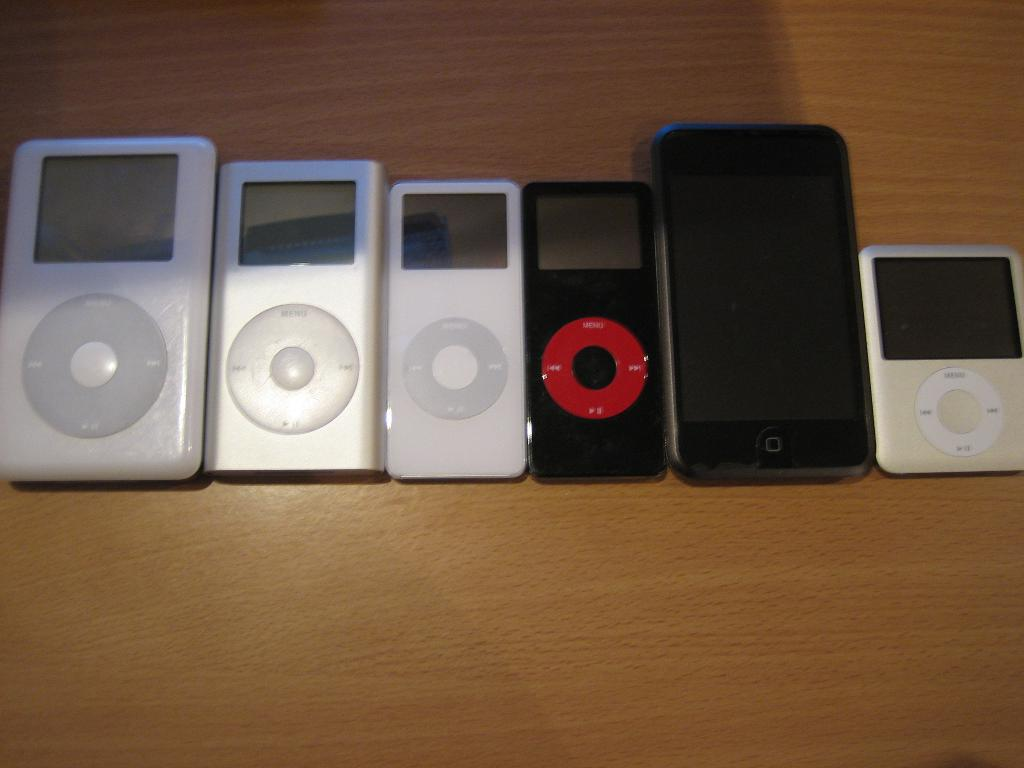What type of objects can be seen in the image? There are electronic gadgets in the image. Where are the electronic gadgets located? The electronic gadgets are placed on a table. How many lamps are visible in the image? There is no lamp present in the image; it only features electronic gadgets placed on a table. 